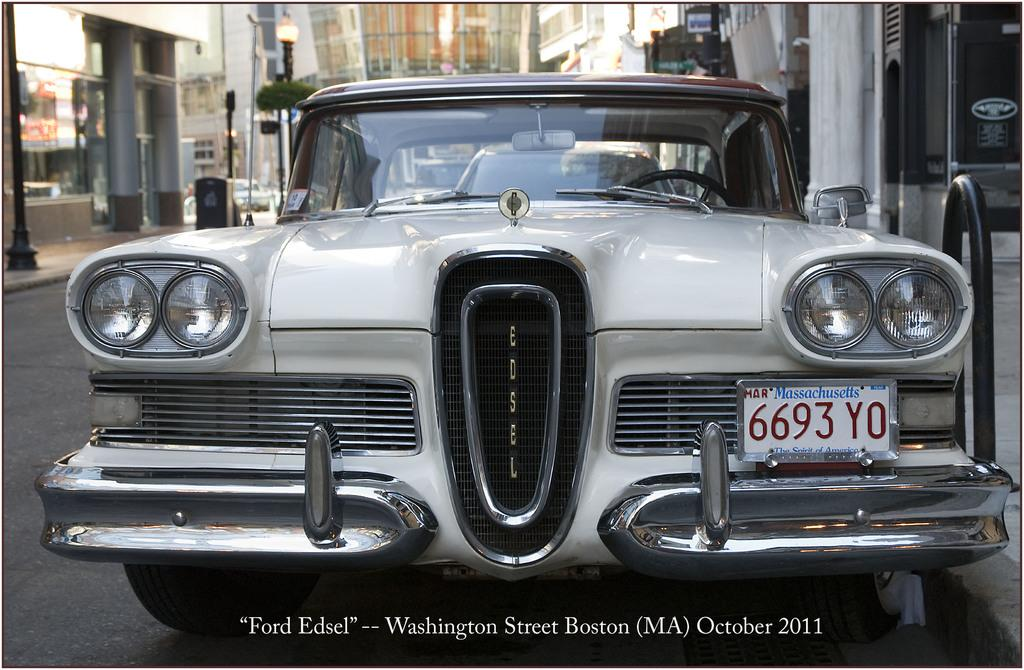Provide a one-sentence caption for the provided image. In Massachusetts someone owns a Ford Edsel with a tag reading 6693 YO. 